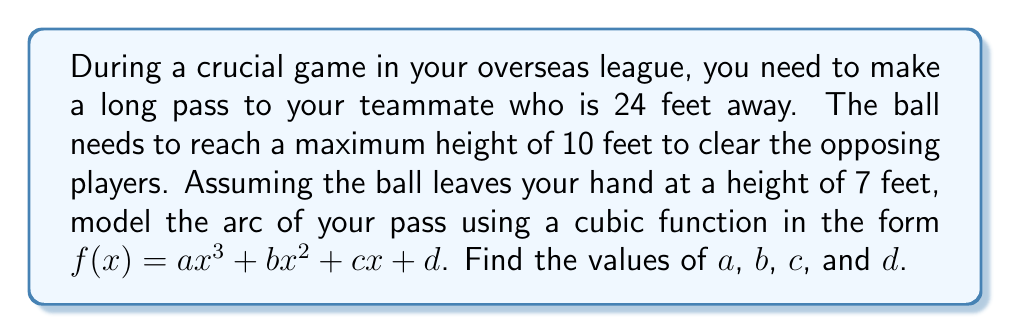Could you help me with this problem? Let's approach this step-by-step:

1) We know that the cubic function will be in the form $f(x) = ax^3 + bx^2 + cx + d$.

2) We have four conditions that this function must satisfy:
   a) At $x = 0$, $f(0) = 7$ (starting height)
   b) At $x = 24$, $f(24) = 7$ (ending height)
   c) At $x = 24$, $f'(24) = 0$ (horizontal tangent at the end)
   d) The maximum of the function occurs at $x = 12$ (halfway) and $f(12) = 10$

3) From condition (a): $f(0) = d = 7$

4) From condition (b): $f(24) = a(24^3) + b(24^2) + c(24) + 7 = 7$
   $\Rightarrow 13824a + 576b + 24c = 0$ ... (Equation 1)

5) From condition (c): $f'(x) = 3ax^2 + 2bx + c$
   $f'(24) = 3a(24^2) + 2b(24) + c = 0$
   $\Rightarrow 1728a + 48b + c = 0$ ... (Equation 2)

6) From condition (d): $f(12) = a(12^3) + b(12^2) + c(12) + 7 = 10$
   $\Rightarrow 1728a + 144b + 12c = 3$ ... (Equation 3)

7) Now we have a system of three equations with three unknowns:
   13824a + 576b + 24c = 0
   1728a + 48b + c = 0
   1728a + 144b + 12c = 3

8) Solving this system (you can use elimination or substitution method):
   $a = -\frac{1}{2304}$
   $b = \frac{1}{32}$
   $c = 0$

9) Therefore, the cubic function is:
   $f(x) = -\frac{1}{2304}x^3 + \frac{1}{32}x^2 + 7$
Answer: $a = -\frac{1}{2304}$, $b = \frac{1}{32}$, $c = 0$, $d = 7$ 